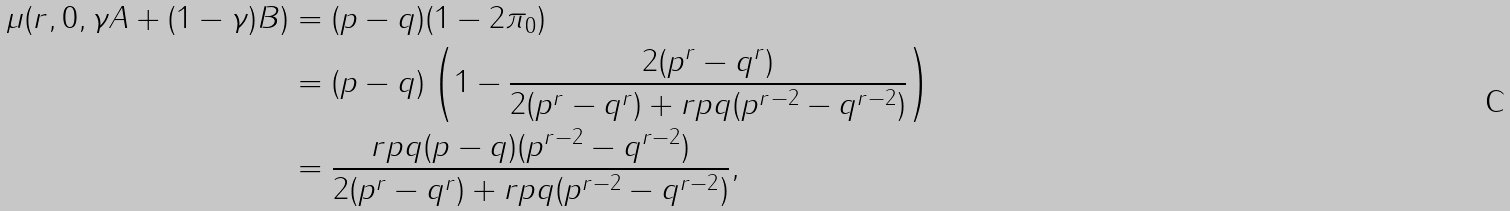Convert formula to latex. <formula><loc_0><loc_0><loc_500><loc_500>\mu ( r , 0 , \gamma A + ( 1 - \gamma ) B ) & = ( p - q ) ( 1 - 2 \pi _ { 0 } ) \\ & = ( p - q ) \left ( 1 - \frac { 2 ( p ^ { r } - q ^ { r } ) } { 2 ( p ^ { r } - q ^ { r } ) + r p q ( p ^ { r - 2 } - q ^ { r - 2 } ) } \right ) \\ & = \frac { r p q ( p - q ) ( p ^ { r - 2 } - q ^ { r - 2 } ) } { 2 ( p ^ { r } - q ^ { r } ) + r p q ( p ^ { r - 2 } - q ^ { r - 2 } ) } ,</formula> 